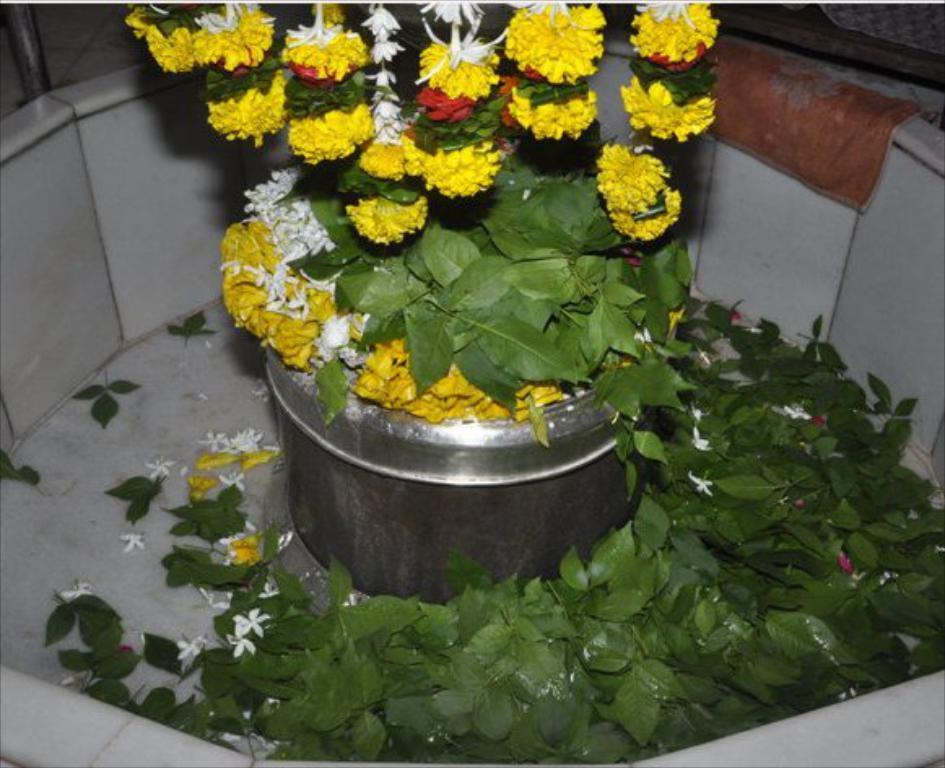In one or two sentences, can you explain what this image depicts? In this image in the center there is one flower pot and some flowers, at the bottom there are some leaves and in the background it looks like a wall. On the wall there is some cloth. 